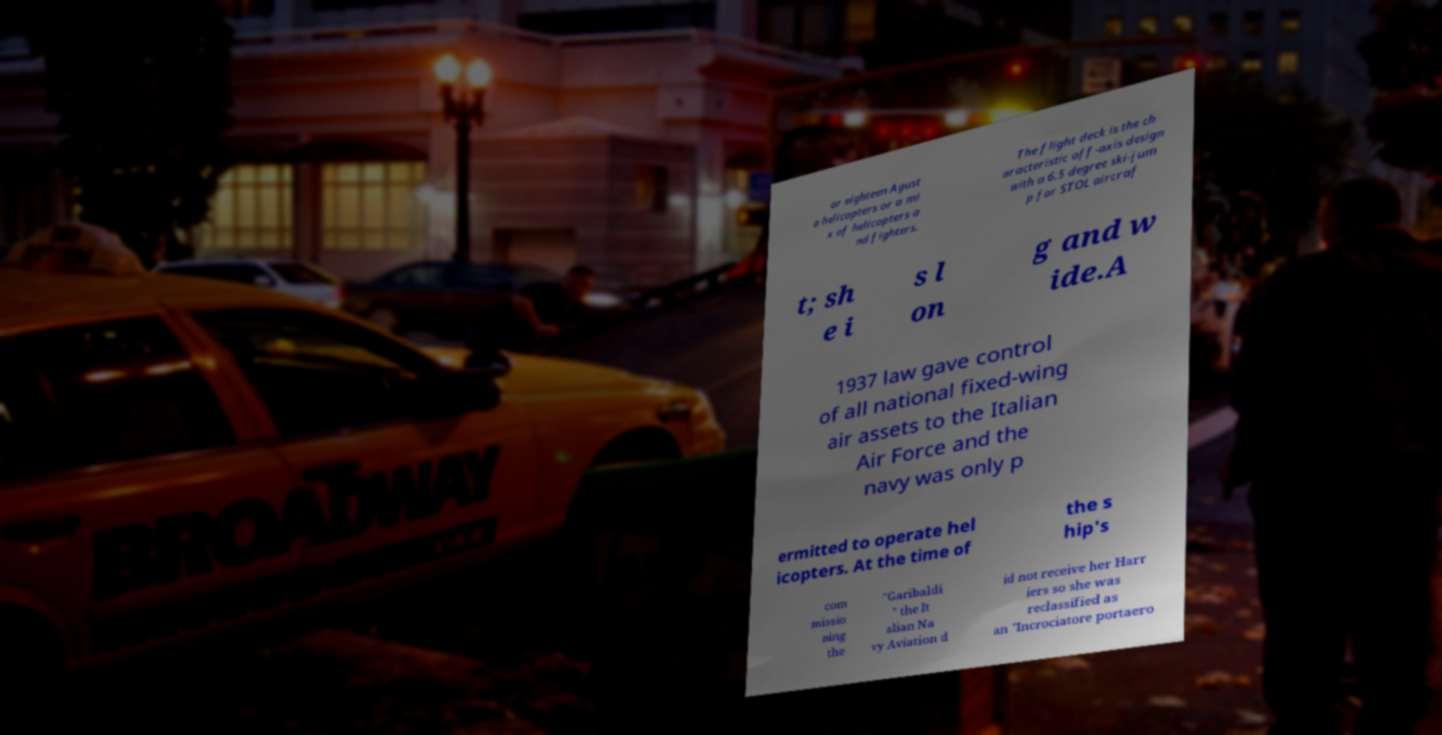Please identify and transcribe the text found in this image. or eighteen Agust a helicopters or a mi x of helicopters a nd fighters. The flight deck is the ch aracteristic off-axis design with a 6.5 degree ski-jum p for STOL aircraf t; sh e i s l on g and w ide.A 1937 law gave control of all national fixed-wing air assets to the Italian Air Force and the navy was only p ermitted to operate hel icopters. At the time of the s hip's com missio ning the "Garibaldi " the It alian Na vy Aviation d id not receive her Harr iers so she was reclassified as an "Incrociatore portaero 